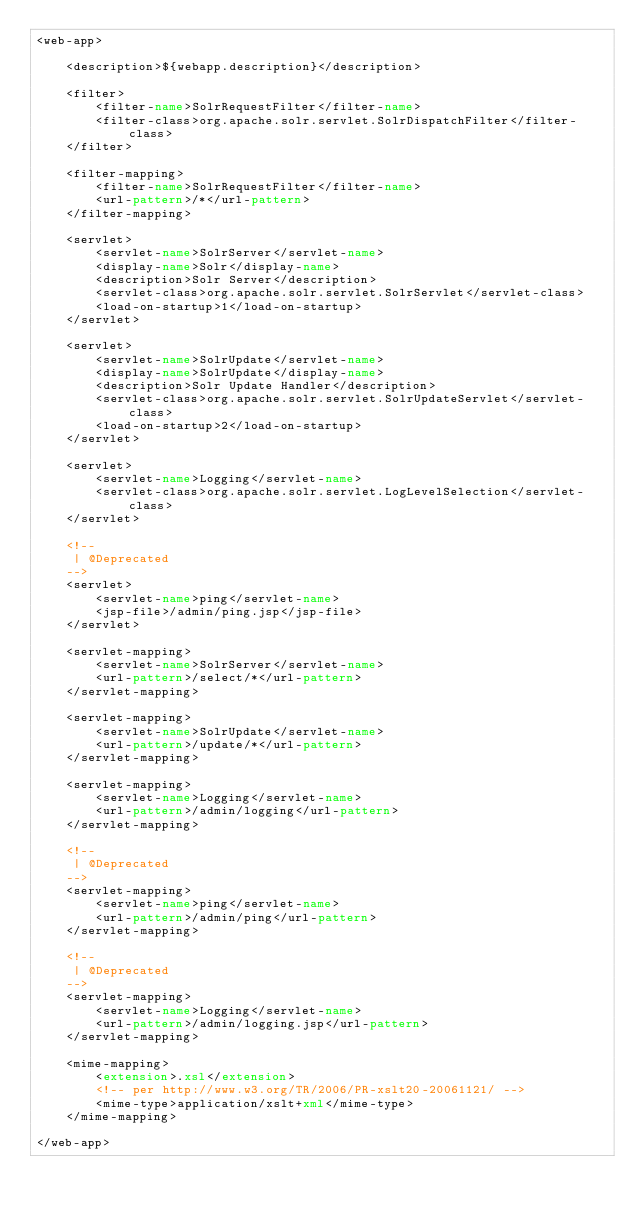Convert code to text. <code><loc_0><loc_0><loc_500><loc_500><_XML_><web-app>

    <description>${webapp.description}</description>

    <filter>
        <filter-name>SolrRequestFilter</filter-name>
        <filter-class>org.apache.solr.servlet.SolrDispatchFilter</filter-class>
    </filter>

    <filter-mapping>
        <filter-name>SolrRequestFilter</filter-name>
        <url-pattern>/*</url-pattern>
    </filter-mapping>

    <servlet>
        <servlet-name>SolrServer</servlet-name>
        <display-name>Solr</display-name>
        <description>Solr Server</description>
        <servlet-class>org.apache.solr.servlet.SolrServlet</servlet-class>
        <load-on-startup>1</load-on-startup>
    </servlet>

    <servlet>
        <servlet-name>SolrUpdate</servlet-name>
        <display-name>SolrUpdate</display-name>
        <description>Solr Update Handler</description>
        <servlet-class>org.apache.solr.servlet.SolrUpdateServlet</servlet-class>
        <load-on-startup>2</load-on-startup>
    </servlet>

    <servlet>
        <servlet-name>Logging</servlet-name>
        <servlet-class>org.apache.solr.servlet.LogLevelSelection</servlet-class>
    </servlet>

    <!--
     | @Deprecated
    -->
    <servlet>
        <servlet-name>ping</servlet-name>
        <jsp-file>/admin/ping.jsp</jsp-file>
    </servlet>

    <servlet-mapping>
        <servlet-name>SolrServer</servlet-name>
        <url-pattern>/select/*</url-pattern>
    </servlet-mapping>

    <servlet-mapping>
        <servlet-name>SolrUpdate</servlet-name>
        <url-pattern>/update/*</url-pattern>
    </servlet-mapping>

    <servlet-mapping>
        <servlet-name>Logging</servlet-name>
        <url-pattern>/admin/logging</url-pattern>
    </servlet-mapping>

    <!--
     | @Deprecated
    -->
    <servlet-mapping>
        <servlet-name>ping</servlet-name>
        <url-pattern>/admin/ping</url-pattern>
    </servlet-mapping>

    <!--
     | @Deprecated
    -->
    <servlet-mapping>
        <servlet-name>Logging</servlet-name>
        <url-pattern>/admin/logging.jsp</url-pattern>
    </servlet-mapping>

    <mime-mapping>
        <extension>.xsl</extension>
        <!-- per http://www.w3.org/TR/2006/PR-xslt20-20061121/ -->
        <mime-type>application/xslt+xml</mime-type>
    </mime-mapping>

</web-app>
</code> 